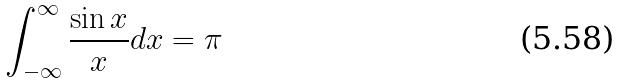<formula> <loc_0><loc_0><loc_500><loc_500>\int _ { - \infty } ^ { \infty } \frac { \sin x } { x } d x = \pi</formula> 